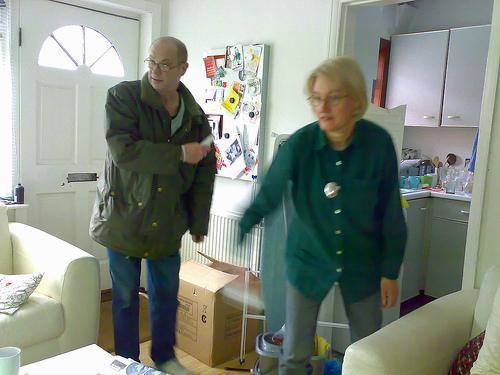How many people are in the photo?
Give a very brief answer. 2. How many people are in the living room?
Give a very brief answer. 2. How many people are reading book?
Give a very brief answer. 0. 